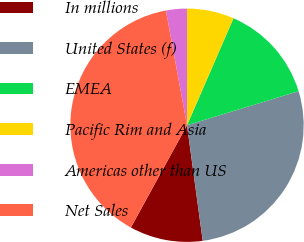Convert chart to OTSL. <chart><loc_0><loc_0><loc_500><loc_500><pie_chart><fcel>In millions<fcel>United States (f)<fcel>EMEA<fcel>Pacific Rim and Asia<fcel>Americas other than US<fcel>Net Sales<nl><fcel>10.14%<fcel>27.57%<fcel>13.76%<fcel>6.52%<fcel>2.9%<fcel>39.12%<nl></chart> 